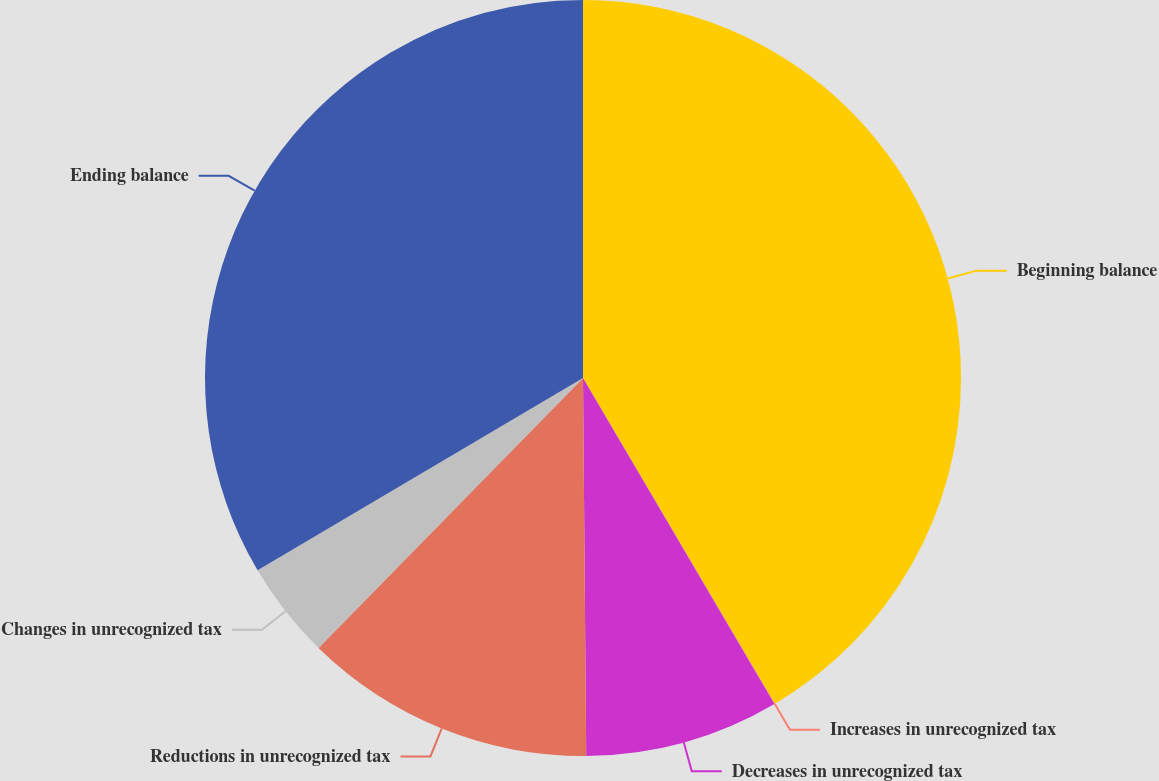Convert chart. <chart><loc_0><loc_0><loc_500><loc_500><pie_chart><fcel>Beginning balance<fcel>Increases in unrecognized tax<fcel>Decreases in unrecognized tax<fcel>Reductions in unrecognized tax<fcel>Changes in unrecognized tax<fcel>Ending balance<nl><fcel>41.53%<fcel>0.02%<fcel>8.32%<fcel>12.47%<fcel>4.17%<fcel>33.5%<nl></chart> 